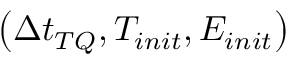Convert formula to latex. <formula><loc_0><loc_0><loc_500><loc_500>\left ( \Delta t _ { T Q } , T _ { i n i t } , E _ { i n i t } \right )</formula> 